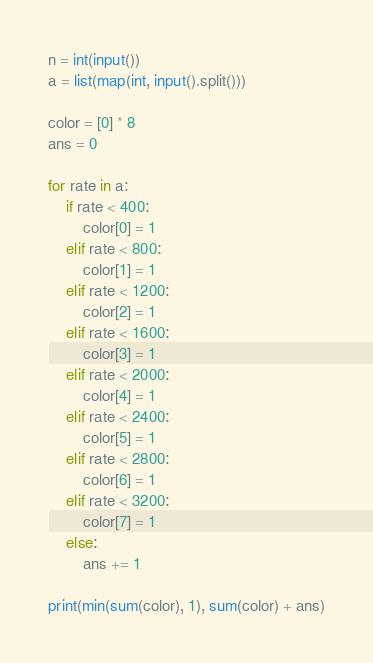Convert code to text. <code><loc_0><loc_0><loc_500><loc_500><_Python_>n = int(input())
a = list(map(int, input().split()))

color = [0] * 8
ans = 0

for rate in a:
    if rate < 400:
        color[0] = 1
    elif rate < 800:
        color[1] = 1
    elif rate < 1200:
        color[2] = 1
    elif rate < 1600:
        color[3] = 1
    elif rate < 2000:
        color[4] = 1
    elif rate < 2400:
        color[5] = 1
    elif rate < 2800:
        color[6] = 1
    elif rate < 3200:
        color[7] = 1
    else:
        ans += 1

print(min(sum(color), 1), sum(color) + ans)</code> 